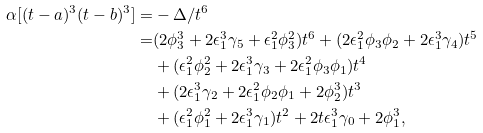Convert formula to latex. <formula><loc_0><loc_0><loc_500><loc_500>\alpha [ ( t - a ) ^ { 3 } ( t - b ) ^ { 3 } ] = & - \Delta / t ^ { 6 } \\ = & ( 2 \phi _ { 3 } ^ { 3 } + 2 { \epsilon } _ { 1 } ^ { 3 } \gamma _ { 5 } + { \epsilon } _ { 1 } ^ { 2 } \phi _ { 3 } ^ { 2 } ) t ^ { 6 } + ( 2 { \epsilon } _ { 1 } ^ { 2 } \phi _ { 3 } \phi _ { 2 } + 2 { \epsilon } _ { 1 } ^ { 3 } \gamma _ { 4 } ) t ^ { 5 } \\ & + ( { \epsilon } _ { 1 } ^ { 2 } \phi _ { 2 } ^ { 2 } + 2 { \epsilon } _ { 1 } ^ { 3 } \gamma _ { 3 } + 2 { \epsilon } _ { 1 } ^ { 2 } \phi _ { 3 } \phi _ { 1 } ) t ^ { 4 } \\ & + ( 2 { \epsilon } _ { 1 } ^ { 3 } \gamma _ { 2 } + 2 { \epsilon } _ { 1 } ^ { 2 } \phi _ { 2 } \phi _ { 1 } + 2 \phi _ { 2 } ^ { 3 } ) t ^ { 3 } \\ & + ( { \epsilon } _ { 1 } ^ { 2 } \phi _ { 1 } ^ { 2 } + 2 { \epsilon } _ { 1 } ^ { 3 } \gamma _ { 1 } ) t ^ { 2 } + 2 t { \epsilon } _ { 1 } ^ { 3 } \gamma _ { 0 } + 2 \phi _ { 1 } ^ { 3 } ,</formula> 